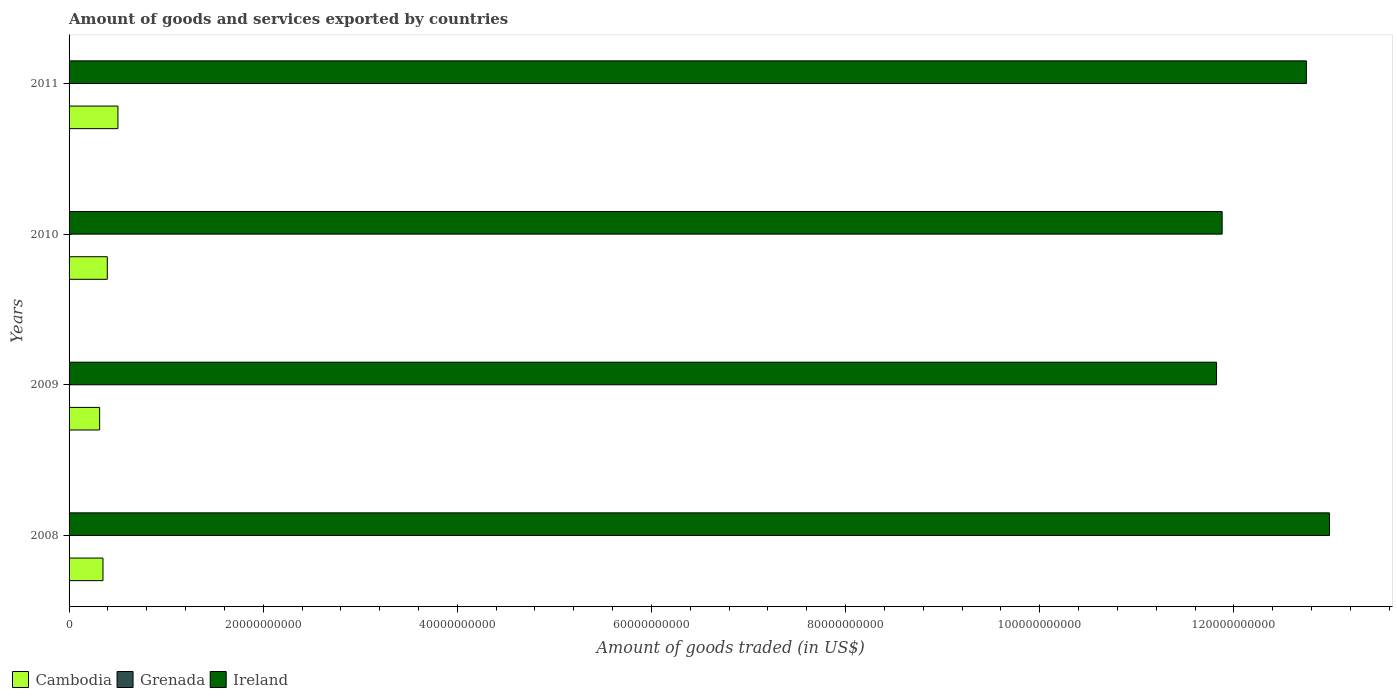How many different coloured bars are there?
Provide a short and direct response. 3. How many groups of bars are there?
Give a very brief answer. 4. Are the number of bars per tick equal to the number of legend labels?
Ensure brevity in your answer.  Yes. How many bars are there on the 2nd tick from the top?
Offer a terse response. 3. How many bars are there on the 3rd tick from the bottom?
Make the answer very short. 3. What is the label of the 1st group of bars from the top?
Make the answer very short. 2011. What is the total amount of goods and services exported in Cambodia in 2009?
Give a very brief answer. 3.15e+09. Across all years, what is the maximum total amount of goods and services exported in Grenada?
Offer a very short reply. 4.05e+07. Across all years, what is the minimum total amount of goods and services exported in Grenada?
Make the answer very short. 3.11e+07. In which year was the total amount of goods and services exported in Ireland maximum?
Offer a very short reply. 2008. In which year was the total amount of goods and services exported in Cambodia minimum?
Make the answer very short. 2009. What is the total total amount of goods and services exported in Grenada in the graph?
Offer a terse response. 1.44e+08. What is the difference between the total amount of goods and services exported in Grenada in 2009 and that in 2010?
Give a very brief answer. 4.17e+06. What is the difference between the total amount of goods and services exported in Ireland in 2009 and the total amount of goods and services exported in Cambodia in 2011?
Offer a terse response. 1.13e+11. What is the average total amount of goods and services exported in Ireland per year?
Your answer should be compact. 1.24e+11. In the year 2008, what is the difference between the total amount of goods and services exported in Ireland and total amount of goods and services exported in Grenada?
Your answer should be very brief. 1.30e+11. In how many years, is the total amount of goods and services exported in Grenada greater than 100000000000 US$?
Provide a short and direct response. 0. What is the ratio of the total amount of goods and services exported in Cambodia in 2008 to that in 2009?
Provide a short and direct response. 1.11. Is the total amount of goods and services exported in Grenada in 2009 less than that in 2010?
Provide a succinct answer. No. Is the difference between the total amount of goods and services exported in Ireland in 2008 and 2009 greater than the difference between the total amount of goods and services exported in Grenada in 2008 and 2009?
Your answer should be compact. Yes. What is the difference between the highest and the second highest total amount of goods and services exported in Ireland?
Provide a succinct answer. 2.38e+09. What is the difference between the highest and the lowest total amount of goods and services exported in Grenada?
Your answer should be very brief. 9.34e+06. Is the sum of the total amount of goods and services exported in Grenada in 2009 and 2011 greater than the maximum total amount of goods and services exported in Cambodia across all years?
Your response must be concise. No. What does the 3rd bar from the top in 2008 represents?
Offer a terse response. Cambodia. What does the 2nd bar from the bottom in 2009 represents?
Your answer should be very brief. Grenada. How many bars are there?
Provide a short and direct response. 12. Are all the bars in the graph horizontal?
Offer a terse response. Yes. How many years are there in the graph?
Ensure brevity in your answer.  4. What is the difference between two consecutive major ticks on the X-axis?
Your answer should be compact. 2.00e+1. Are the values on the major ticks of X-axis written in scientific E-notation?
Offer a very short reply. No. Where does the legend appear in the graph?
Your answer should be compact. Bottom left. How many legend labels are there?
Your answer should be very brief. 3. What is the title of the graph?
Make the answer very short. Amount of goods and services exported by countries. Does "Vietnam" appear as one of the legend labels in the graph?
Your answer should be compact. No. What is the label or title of the X-axis?
Offer a very short reply. Amount of goods traded (in US$). What is the Amount of goods traded (in US$) of Cambodia in 2008?
Provide a succinct answer. 3.49e+09. What is the Amount of goods traded (in US$) of Grenada in 2008?
Ensure brevity in your answer.  4.05e+07. What is the Amount of goods traded (in US$) in Ireland in 2008?
Ensure brevity in your answer.  1.30e+11. What is the Amount of goods traded (in US$) in Cambodia in 2009?
Offer a very short reply. 3.15e+09. What is the Amount of goods traded (in US$) of Grenada in 2009?
Ensure brevity in your answer.  3.53e+07. What is the Amount of goods traded (in US$) in Ireland in 2009?
Provide a short and direct response. 1.18e+11. What is the Amount of goods traded (in US$) of Cambodia in 2010?
Provide a short and direct response. 3.94e+09. What is the Amount of goods traded (in US$) of Grenada in 2010?
Keep it short and to the point. 3.11e+07. What is the Amount of goods traded (in US$) of Ireland in 2010?
Your answer should be compact. 1.19e+11. What is the Amount of goods traded (in US$) in Cambodia in 2011?
Your response must be concise. 5.03e+09. What is the Amount of goods traded (in US$) in Grenada in 2011?
Make the answer very short. 3.72e+07. What is the Amount of goods traded (in US$) of Ireland in 2011?
Provide a succinct answer. 1.27e+11. Across all years, what is the maximum Amount of goods traded (in US$) in Cambodia?
Offer a very short reply. 5.03e+09. Across all years, what is the maximum Amount of goods traded (in US$) in Grenada?
Provide a short and direct response. 4.05e+07. Across all years, what is the maximum Amount of goods traded (in US$) of Ireland?
Make the answer very short. 1.30e+11. Across all years, what is the minimum Amount of goods traded (in US$) in Cambodia?
Your answer should be compact. 3.15e+09. Across all years, what is the minimum Amount of goods traded (in US$) of Grenada?
Keep it short and to the point. 3.11e+07. Across all years, what is the minimum Amount of goods traded (in US$) of Ireland?
Your answer should be very brief. 1.18e+11. What is the total Amount of goods traded (in US$) of Cambodia in the graph?
Keep it short and to the point. 1.56e+1. What is the total Amount of goods traded (in US$) of Grenada in the graph?
Offer a terse response. 1.44e+08. What is the total Amount of goods traded (in US$) of Ireland in the graph?
Give a very brief answer. 4.94e+11. What is the difference between the Amount of goods traded (in US$) in Cambodia in 2008 and that in 2009?
Provide a short and direct response. 3.45e+08. What is the difference between the Amount of goods traded (in US$) in Grenada in 2008 and that in 2009?
Your response must be concise. 5.17e+06. What is the difference between the Amount of goods traded (in US$) of Ireland in 2008 and that in 2009?
Your answer should be compact. 1.16e+1. What is the difference between the Amount of goods traded (in US$) of Cambodia in 2008 and that in 2010?
Make the answer very short. -4.45e+08. What is the difference between the Amount of goods traded (in US$) in Grenada in 2008 and that in 2010?
Offer a very short reply. 9.34e+06. What is the difference between the Amount of goods traded (in US$) in Ireland in 2008 and that in 2010?
Your answer should be compact. 1.11e+1. What is the difference between the Amount of goods traded (in US$) in Cambodia in 2008 and that in 2011?
Provide a short and direct response. -1.54e+09. What is the difference between the Amount of goods traded (in US$) in Grenada in 2008 and that in 2011?
Offer a terse response. 3.31e+06. What is the difference between the Amount of goods traded (in US$) of Ireland in 2008 and that in 2011?
Keep it short and to the point. 2.38e+09. What is the difference between the Amount of goods traded (in US$) in Cambodia in 2009 and that in 2010?
Ensure brevity in your answer.  -7.91e+08. What is the difference between the Amount of goods traded (in US$) in Grenada in 2009 and that in 2010?
Make the answer very short. 4.17e+06. What is the difference between the Amount of goods traded (in US$) in Ireland in 2009 and that in 2010?
Give a very brief answer. -5.77e+08. What is the difference between the Amount of goods traded (in US$) of Cambodia in 2009 and that in 2011?
Ensure brevity in your answer.  -1.89e+09. What is the difference between the Amount of goods traded (in US$) of Grenada in 2009 and that in 2011?
Your answer should be compact. -1.86e+06. What is the difference between the Amount of goods traded (in US$) of Ireland in 2009 and that in 2011?
Keep it short and to the point. -9.26e+09. What is the difference between the Amount of goods traded (in US$) in Cambodia in 2010 and that in 2011?
Give a very brief answer. -1.10e+09. What is the difference between the Amount of goods traded (in US$) in Grenada in 2010 and that in 2011?
Make the answer very short. -6.03e+06. What is the difference between the Amount of goods traded (in US$) in Ireland in 2010 and that in 2011?
Keep it short and to the point. -8.68e+09. What is the difference between the Amount of goods traded (in US$) in Cambodia in 2008 and the Amount of goods traded (in US$) in Grenada in 2009?
Offer a very short reply. 3.46e+09. What is the difference between the Amount of goods traded (in US$) of Cambodia in 2008 and the Amount of goods traded (in US$) of Ireland in 2009?
Make the answer very short. -1.15e+11. What is the difference between the Amount of goods traded (in US$) of Grenada in 2008 and the Amount of goods traded (in US$) of Ireland in 2009?
Give a very brief answer. -1.18e+11. What is the difference between the Amount of goods traded (in US$) in Cambodia in 2008 and the Amount of goods traded (in US$) in Grenada in 2010?
Provide a short and direct response. 3.46e+09. What is the difference between the Amount of goods traded (in US$) of Cambodia in 2008 and the Amount of goods traded (in US$) of Ireland in 2010?
Give a very brief answer. -1.15e+11. What is the difference between the Amount of goods traded (in US$) in Grenada in 2008 and the Amount of goods traded (in US$) in Ireland in 2010?
Provide a succinct answer. -1.19e+11. What is the difference between the Amount of goods traded (in US$) of Cambodia in 2008 and the Amount of goods traded (in US$) of Grenada in 2011?
Provide a short and direct response. 3.46e+09. What is the difference between the Amount of goods traded (in US$) of Cambodia in 2008 and the Amount of goods traded (in US$) of Ireland in 2011?
Your response must be concise. -1.24e+11. What is the difference between the Amount of goods traded (in US$) of Grenada in 2008 and the Amount of goods traded (in US$) of Ireland in 2011?
Offer a terse response. -1.27e+11. What is the difference between the Amount of goods traded (in US$) in Cambodia in 2009 and the Amount of goods traded (in US$) in Grenada in 2010?
Make the answer very short. 3.12e+09. What is the difference between the Amount of goods traded (in US$) in Cambodia in 2009 and the Amount of goods traded (in US$) in Ireland in 2010?
Offer a terse response. -1.16e+11. What is the difference between the Amount of goods traded (in US$) of Grenada in 2009 and the Amount of goods traded (in US$) of Ireland in 2010?
Keep it short and to the point. -1.19e+11. What is the difference between the Amount of goods traded (in US$) in Cambodia in 2009 and the Amount of goods traded (in US$) in Grenada in 2011?
Your answer should be compact. 3.11e+09. What is the difference between the Amount of goods traded (in US$) in Cambodia in 2009 and the Amount of goods traded (in US$) in Ireland in 2011?
Ensure brevity in your answer.  -1.24e+11. What is the difference between the Amount of goods traded (in US$) in Grenada in 2009 and the Amount of goods traded (in US$) in Ireland in 2011?
Make the answer very short. -1.27e+11. What is the difference between the Amount of goods traded (in US$) of Cambodia in 2010 and the Amount of goods traded (in US$) of Grenada in 2011?
Give a very brief answer. 3.90e+09. What is the difference between the Amount of goods traded (in US$) of Cambodia in 2010 and the Amount of goods traded (in US$) of Ireland in 2011?
Offer a terse response. -1.24e+11. What is the difference between the Amount of goods traded (in US$) in Grenada in 2010 and the Amount of goods traded (in US$) in Ireland in 2011?
Make the answer very short. -1.27e+11. What is the average Amount of goods traded (in US$) in Cambodia per year?
Make the answer very short. 3.90e+09. What is the average Amount of goods traded (in US$) in Grenada per year?
Provide a short and direct response. 3.60e+07. What is the average Amount of goods traded (in US$) in Ireland per year?
Make the answer very short. 1.24e+11. In the year 2008, what is the difference between the Amount of goods traded (in US$) of Cambodia and Amount of goods traded (in US$) of Grenada?
Provide a short and direct response. 3.45e+09. In the year 2008, what is the difference between the Amount of goods traded (in US$) of Cambodia and Amount of goods traded (in US$) of Ireland?
Ensure brevity in your answer.  -1.26e+11. In the year 2008, what is the difference between the Amount of goods traded (in US$) in Grenada and Amount of goods traded (in US$) in Ireland?
Provide a succinct answer. -1.30e+11. In the year 2009, what is the difference between the Amount of goods traded (in US$) in Cambodia and Amount of goods traded (in US$) in Grenada?
Your answer should be very brief. 3.11e+09. In the year 2009, what is the difference between the Amount of goods traded (in US$) in Cambodia and Amount of goods traded (in US$) in Ireland?
Your answer should be very brief. -1.15e+11. In the year 2009, what is the difference between the Amount of goods traded (in US$) in Grenada and Amount of goods traded (in US$) in Ireland?
Your answer should be compact. -1.18e+11. In the year 2010, what is the difference between the Amount of goods traded (in US$) of Cambodia and Amount of goods traded (in US$) of Grenada?
Ensure brevity in your answer.  3.91e+09. In the year 2010, what is the difference between the Amount of goods traded (in US$) in Cambodia and Amount of goods traded (in US$) in Ireland?
Ensure brevity in your answer.  -1.15e+11. In the year 2010, what is the difference between the Amount of goods traded (in US$) in Grenada and Amount of goods traded (in US$) in Ireland?
Offer a terse response. -1.19e+11. In the year 2011, what is the difference between the Amount of goods traded (in US$) in Cambodia and Amount of goods traded (in US$) in Grenada?
Your response must be concise. 5.00e+09. In the year 2011, what is the difference between the Amount of goods traded (in US$) of Cambodia and Amount of goods traded (in US$) of Ireland?
Your answer should be compact. -1.22e+11. In the year 2011, what is the difference between the Amount of goods traded (in US$) of Grenada and Amount of goods traded (in US$) of Ireland?
Give a very brief answer. -1.27e+11. What is the ratio of the Amount of goods traded (in US$) in Cambodia in 2008 to that in 2009?
Provide a succinct answer. 1.11. What is the ratio of the Amount of goods traded (in US$) in Grenada in 2008 to that in 2009?
Your response must be concise. 1.15. What is the ratio of the Amount of goods traded (in US$) in Ireland in 2008 to that in 2009?
Your answer should be compact. 1.1. What is the ratio of the Amount of goods traded (in US$) of Cambodia in 2008 to that in 2010?
Give a very brief answer. 0.89. What is the ratio of the Amount of goods traded (in US$) in Grenada in 2008 to that in 2010?
Your answer should be compact. 1.3. What is the ratio of the Amount of goods traded (in US$) in Ireland in 2008 to that in 2010?
Make the answer very short. 1.09. What is the ratio of the Amount of goods traded (in US$) of Cambodia in 2008 to that in 2011?
Offer a terse response. 0.69. What is the ratio of the Amount of goods traded (in US$) of Grenada in 2008 to that in 2011?
Your response must be concise. 1.09. What is the ratio of the Amount of goods traded (in US$) in Ireland in 2008 to that in 2011?
Offer a very short reply. 1.02. What is the ratio of the Amount of goods traded (in US$) in Cambodia in 2009 to that in 2010?
Ensure brevity in your answer.  0.8. What is the ratio of the Amount of goods traded (in US$) in Grenada in 2009 to that in 2010?
Keep it short and to the point. 1.13. What is the ratio of the Amount of goods traded (in US$) in Ireland in 2009 to that in 2010?
Offer a terse response. 1. What is the ratio of the Amount of goods traded (in US$) of Cambodia in 2009 to that in 2011?
Offer a terse response. 0.63. What is the ratio of the Amount of goods traded (in US$) of Grenada in 2009 to that in 2011?
Provide a succinct answer. 0.95. What is the ratio of the Amount of goods traded (in US$) in Ireland in 2009 to that in 2011?
Keep it short and to the point. 0.93. What is the ratio of the Amount of goods traded (in US$) of Cambodia in 2010 to that in 2011?
Ensure brevity in your answer.  0.78. What is the ratio of the Amount of goods traded (in US$) of Grenada in 2010 to that in 2011?
Keep it short and to the point. 0.84. What is the ratio of the Amount of goods traded (in US$) of Ireland in 2010 to that in 2011?
Provide a short and direct response. 0.93. What is the difference between the highest and the second highest Amount of goods traded (in US$) of Cambodia?
Provide a short and direct response. 1.10e+09. What is the difference between the highest and the second highest Amount of goods traded (in US$) in Grenada?
Make the answer very short. 3.31e+06. What is the difference between the highest and the second highest Amount of goods traded (in US$) in Ireland?
Your answer should be very brief. 2.38e+09. What is the difference between the highest and the lowest Amount of goods traded (in US$) of Cambodia?
Make the answer very short. 1.89e+09. What is the difference between the highest and the lowest Amount of goods traded (in US$) in Grenada?
Your answer should be compact. 9.34e+06. What is the difference between the highest and the lowest Amount of goods traded (in US$) in Ireland?
Ensure brevity in your answer.  1.16e+1. 